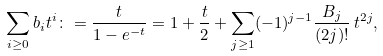<formula> <loc_0><loc_0><loc_500><loc_500>\sum _ { i \geq 0 } b _ { i } t ^ { i } \colon = \frac { t } { 1 - e ^ { - t } } = 1 + \frac { t } { 2 } + \sum _ { j \geq 1 } ( - 1 ) ^ { j - 1 } \frac { B _ { j } } { ( 2 j ) ! } \, t ^ { 2 j } ,</formula> 